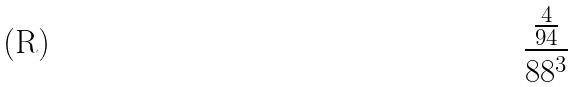<formula> <loc_0><loc_0><loc_500><loc_500>\frac { \frac { 4 } { 9 4 } } { 8 8 ^ { 3 } }</formula> 